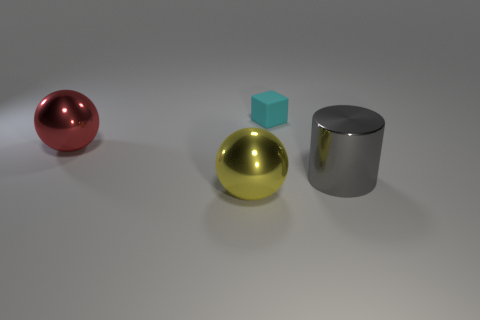Is there anything else that is the same size as the cyan cube?
Provide a succinct answer. No. What material is the big sphere that is in front of the red shiny sphere behind the big metal object that is on the right side of the small cyan rubber thing?
Your response must be concise. Metal. How many other things are there of the same shape as the red metallic object?
Give a very brief answer. 1. There is a big ball that is in front of the big red shiny thing; what color is it?
Provide a short and direct response. Yellow. There is a gray shiny object on the right side of the metallic ball that is to the right of the large red thing; what number of tiny matte objects are in front of it?
Ensure brevity in your answer.  0. What number of yellow things are to the left of the big metal object right of the cyan matte thing?
Your answer should be very brief. 1. There is a tiny cyan block; how many gray cylinders are right of it?
Offer a terse response. 1. What number of other things are there of the same size as the cube?
Provide a short and direct response. 0. What size is the yellow metal object that is the same shape as the big red metal object?
Offer a terse response. Large. The metal thing behind the gray shiny thing has what shape?
Your answer should be very brief. Sphere. 